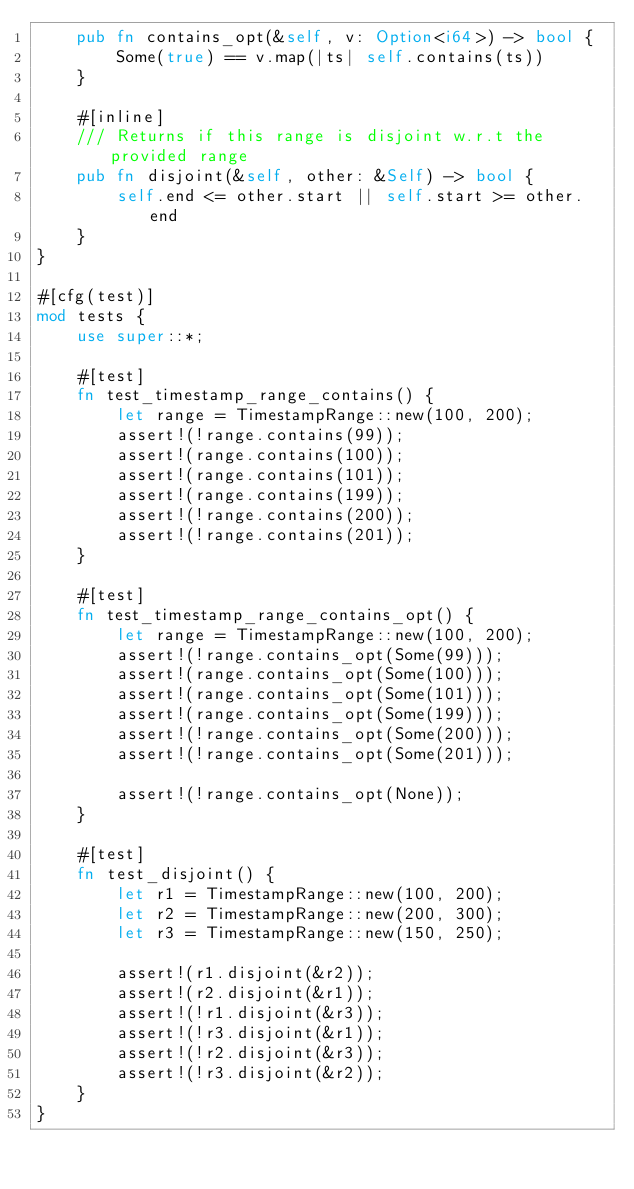<code> <loc_0><loc_0><loc_500><loc_500><_Rust_>    pub fn contains_opt(&self, v: Option<i64>) -> bool {
        Some(true) == v.map(|ts| self.contains(ts))
    }

    #[inline]
    /// Returns if this range is disjoint w.r.t the provided range
    pub fn disjoint(&self, other: &Self) -> bool {
        self.end <= other.start || self.start >= other.end
    }
}

#[cfg(test)]
mod tests {
    use super::*;

    #[test]
    fn test_timestamp_range_contains() {
        let range = TimestampRange::new(100, 200);
        assert!(!range.contains(99));
        assert!(range.contains(100));
        assert!(range.contains(101));
        assert!(range.contains(199));
        assert!(!range.contains(200));
        assert!(!range.contains(201));
    }

    #[test]
    fn test_timestamp_range_contains_opt() {
        let range = TimestampRange::new(100, 200);
        assert!(!range.contains_opt(Some(99)));
        assert!(range.contains_opt(Some(100)));
        assert!(range.contains_opt(Some(101)));
        assert!(range.contains_opt(Some(199)));
        assert!(!range.contains_opt(Some(200)));
        assert!(!range.contains_opt(Some(201)));

        assert!(!range.contains_opt(None));
    }

    #[test]
    fn test_disjoint() {
        let r1 = TimestampRange::new(100, 200);
        let r2 = TimestampRange::new(200, 300);
        let r3 = TimestampRange::new(150, 250);

        assert!(r1.disjoint(&r2));
        assert!(r2.disjoint(&r1));
        assert!(!r1.disjoint(&r3));
        assert!(!r3.disjoint(&r1));
        assert!(!r2.disjoint(&r3));
        assert!(!r3.disjoint(&r2));
    }
}
</code> 